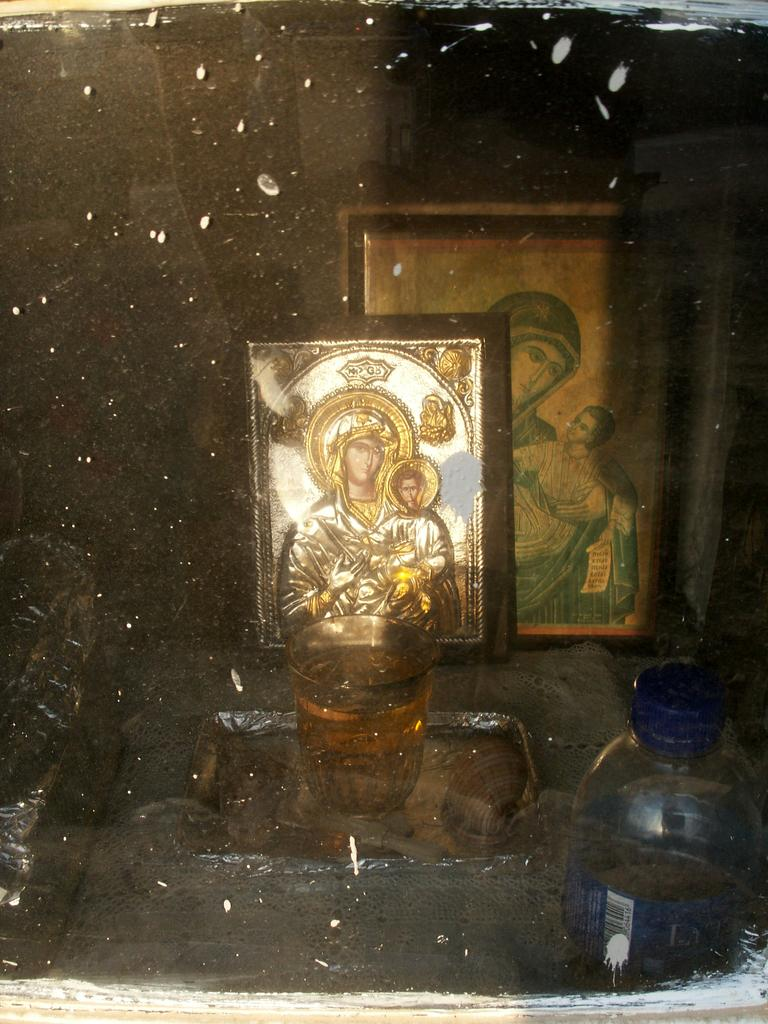What is on the table in the image? There is a glass, a tray, a bottle, and photo frames on the table in the image. Can you describe the glass on the table? The glass is on the table, but its specific characteristics are not mentioned in the facts. What is the purpose of the tray on the table? The purpose of the tray on the table is not mentioned in the facts. What type of object is the bottle on the table? The facts do not specify the type of bottle on the table. How many ducks are peacefully smashing the photo frames in the image? There are no ducks or any smashing activity involving photo frames present in the image. 